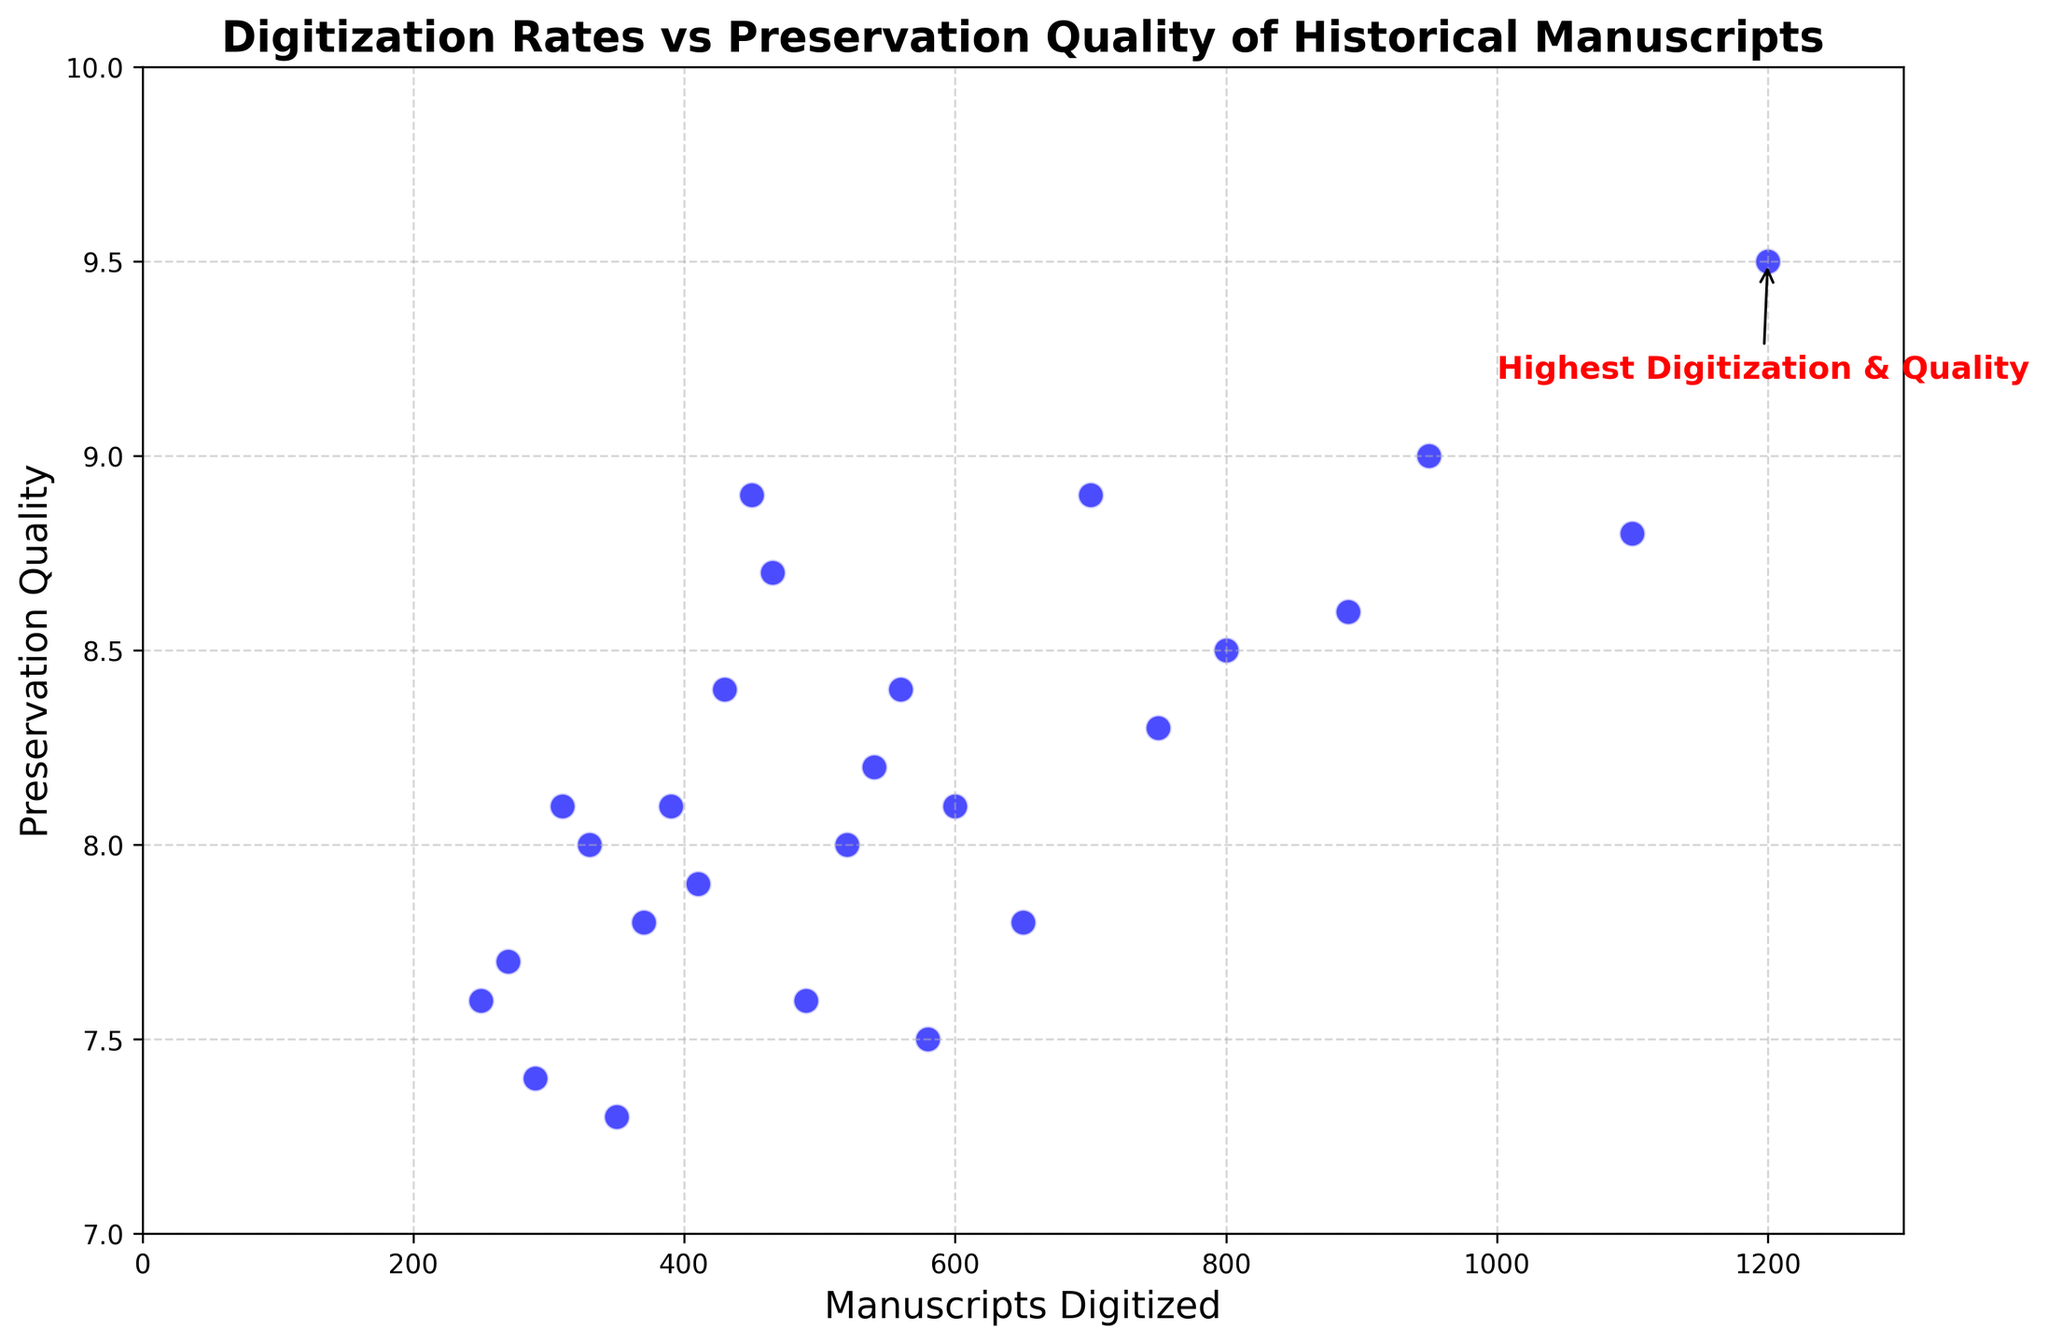what country has the highest preservation quality? The scatter plot shows that the point at the highest Preservation Quality value (9.5) is annotated with "Highest Digitization & Quality," which matches the United States data point.
Answer: United States How does the preservation quality in Sweden compare to that in Canada? By looking at the vertical position of the markers, Sweden has a Preservation Quality of 8.9, and Canada has a Preservation Quality of 8.4. Since 8.9 is greater than 8.4, Sweden has higher preservation quality than Canada.
Answer: Sweden has higher preservation quality than Canada What is the difference between the preservation quality of the United States and Brazil? The Preservation Quality for the United States is 9.5, and for Brazil, it is 7.5. The difference is calculated as 9.5 - 7.5 = 2.0.
Answer: 2.0 Which country has digitized the least number of manuscripts? By looking at the horizontal positions on the scatter plot, Greece is the leftmost point, indicating it has digitized the least number of manuscripts with 250.
Answer: Greece Is the preservation quality in South Korea higher than in France? By comparing the vertical positions of South Korea and France, South Korea has a Preservation Quality of 8.7, while France has a Preservation Quality of 8.6. Since 8.7 is greater than 8.6, South Korea has higher preservation quality.
Answer: Yes, South Korea has higher preservation quality than France Which country is closest in digitization rate to India? By examining the plot, China, with 600 manuscripts digitized, is the closest to India, which has 650 manuscripts digitized.
Answer: China What is the combined total number of manuscripts digitized in Italy and Spain? Italy has digitized 800 manuscripts, and Spain has digitized 750. Combining them gives 800 + 750 = 1550 manuscripts.
Answer: 1550 Does Japan have a higher preservation quality than Germany? Japan's Preservation Quality is 8.9, and Germany's is 9.0. Since 8.9 is less than 9.0, Japan does not have higher preservation quality than Germany.
Answer: No, Japan does not have higher preservation quality than Germany Which country has the highest digitization rate, and what is its preservation quality? The label on the highest horizontal point shows the United States has digitized the most manuscripts, with a preservation quality of 9.5.
Answer: United States, 9.5 